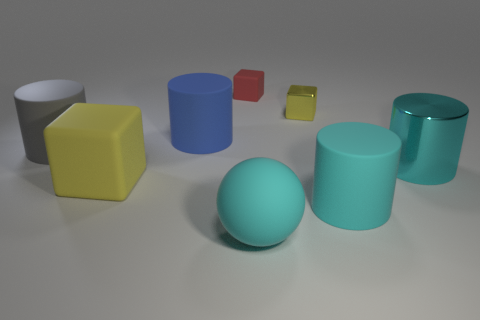How many cyan cylinders must be subtracted to get 1 cyan cylinders? 1 Subtract all purple cylinders. Subtract all brown spheres. How many cylinders are left? 4 Add 2 big yellow metallic spheres. How many objects exist? 10 Subtract all spheres. How many objects are left? 7 Subtract 0 purple balls. How many objects are left? 8 Subtract all small blocks. Subtract all gray cylinders. How many objects are left? 5 Add 7 spheres. How many spheres are left? 8 Add 6 cyan metallic cylinders. How many cyan metallic cylinders exist? 7 